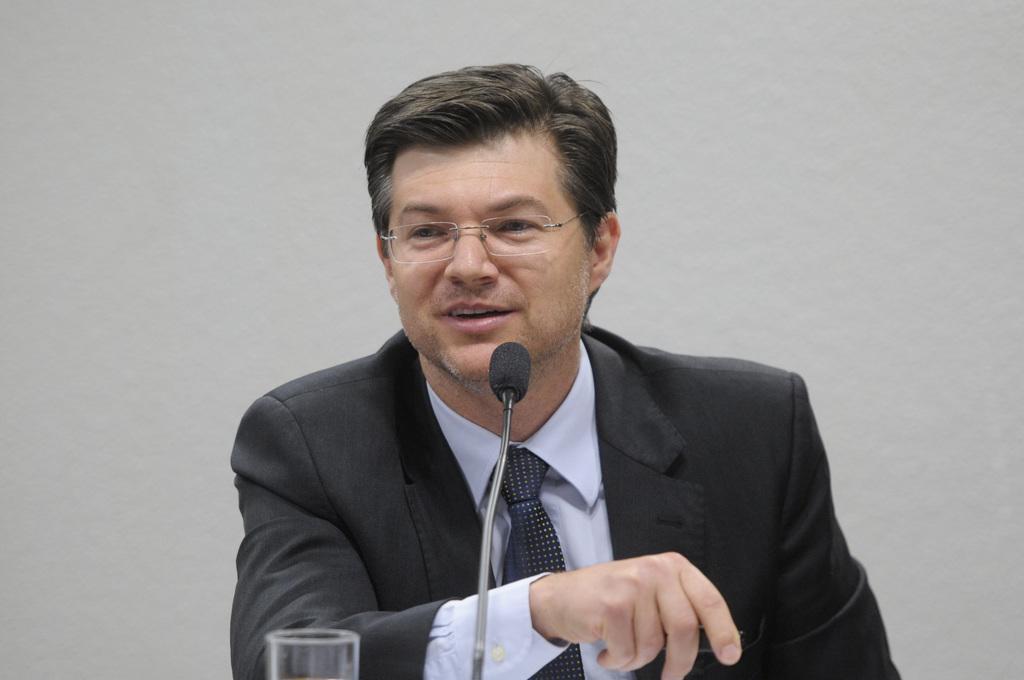In one or two sentences, can you explain what this image depicts? In the image there is a man with black jacket, blue shirt and tie is sitting and he kept spectacles. In front of him there is a mic and a glass. Behind him there is a wall. 